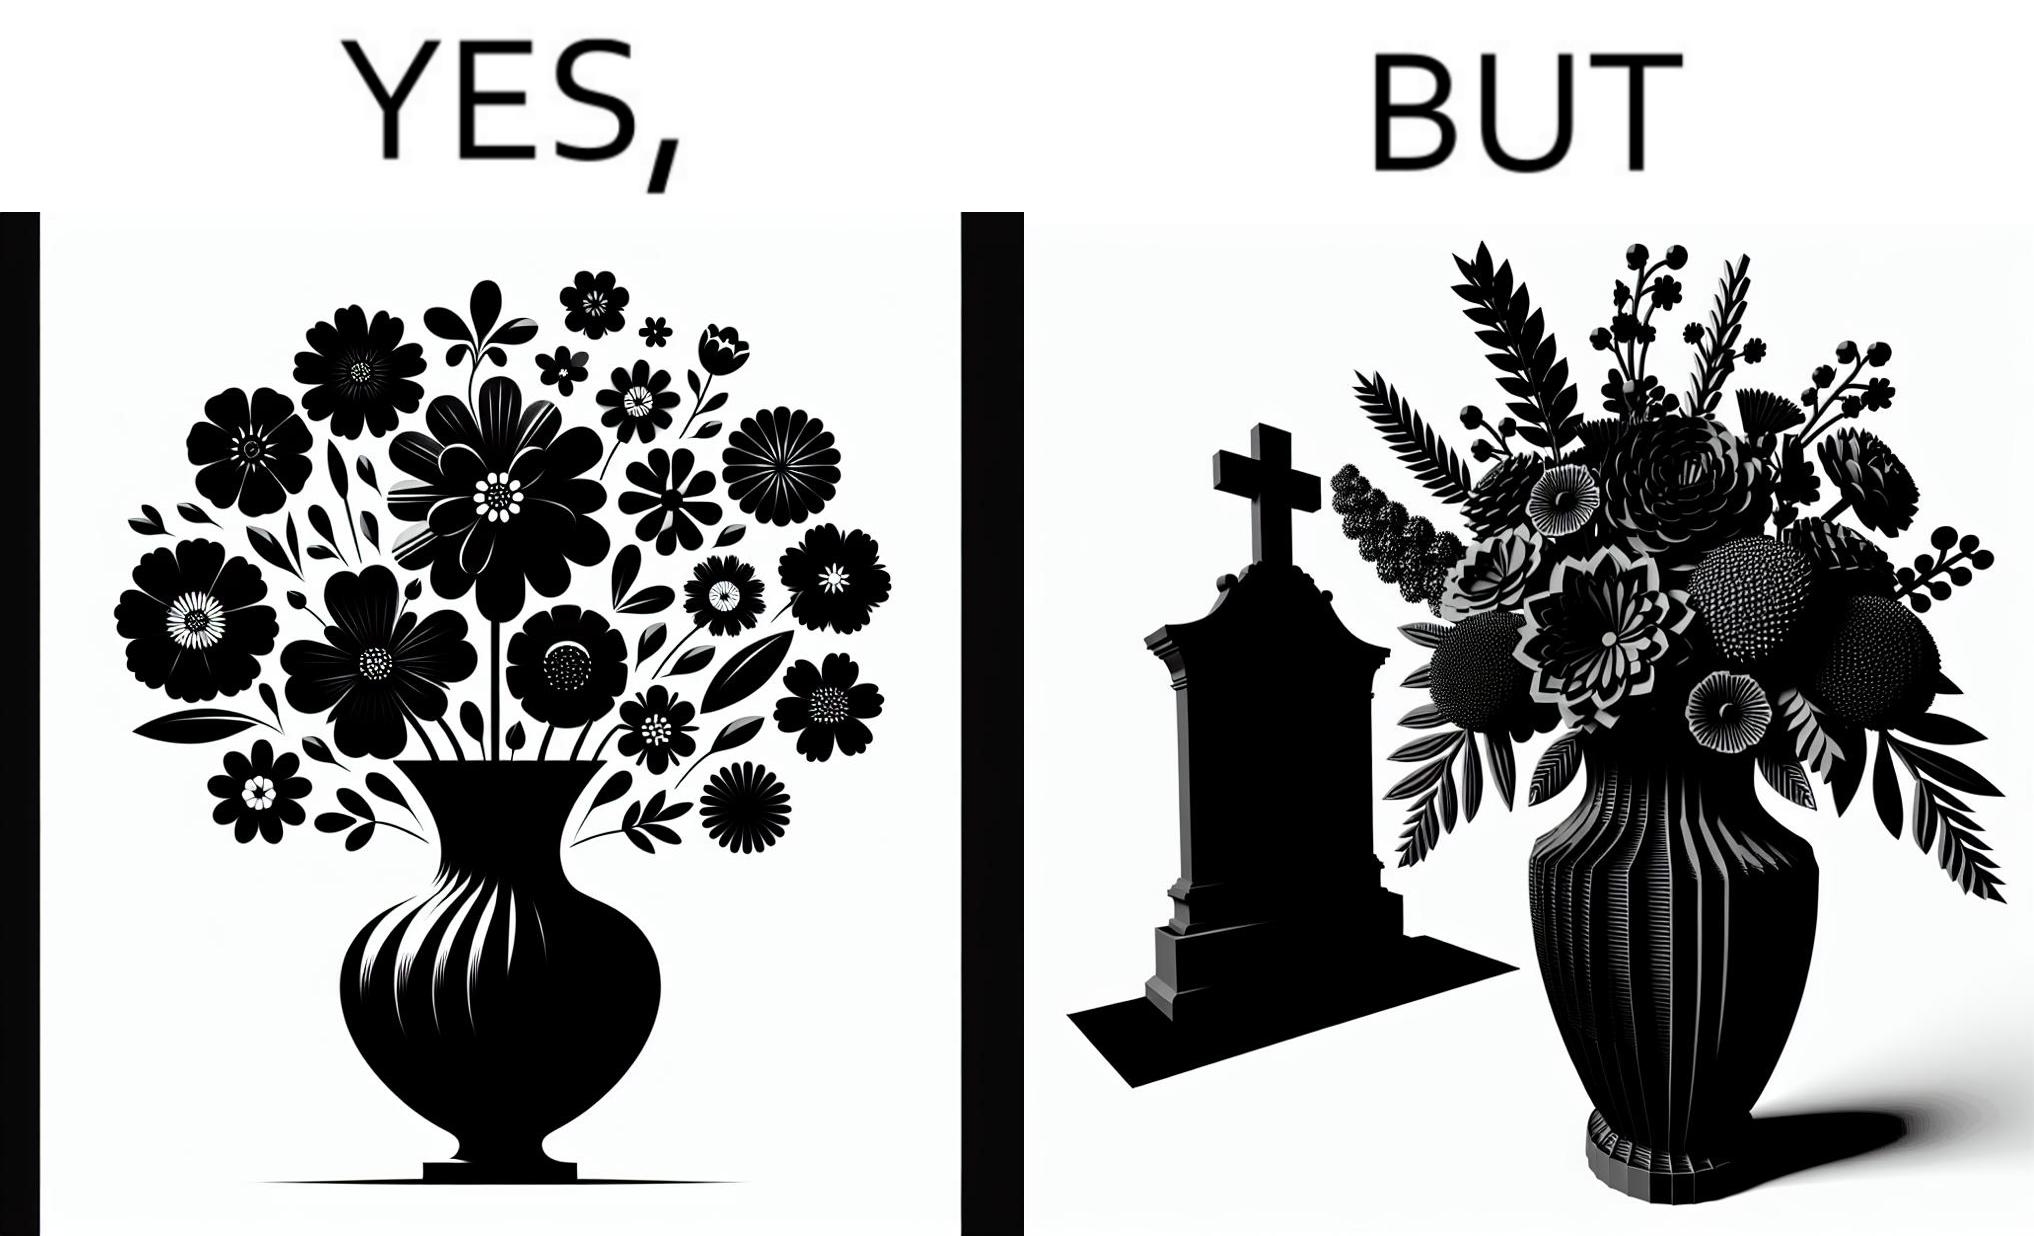Explain why this image is satirical. The image is ironic, because in the first image a vase full of different beautiful flowers is seen which spreads a feeling of positivity, cheerfulness etc., whereas in the second image when the same vase is put in front of a grave stone it produces a feeling of sorrow 